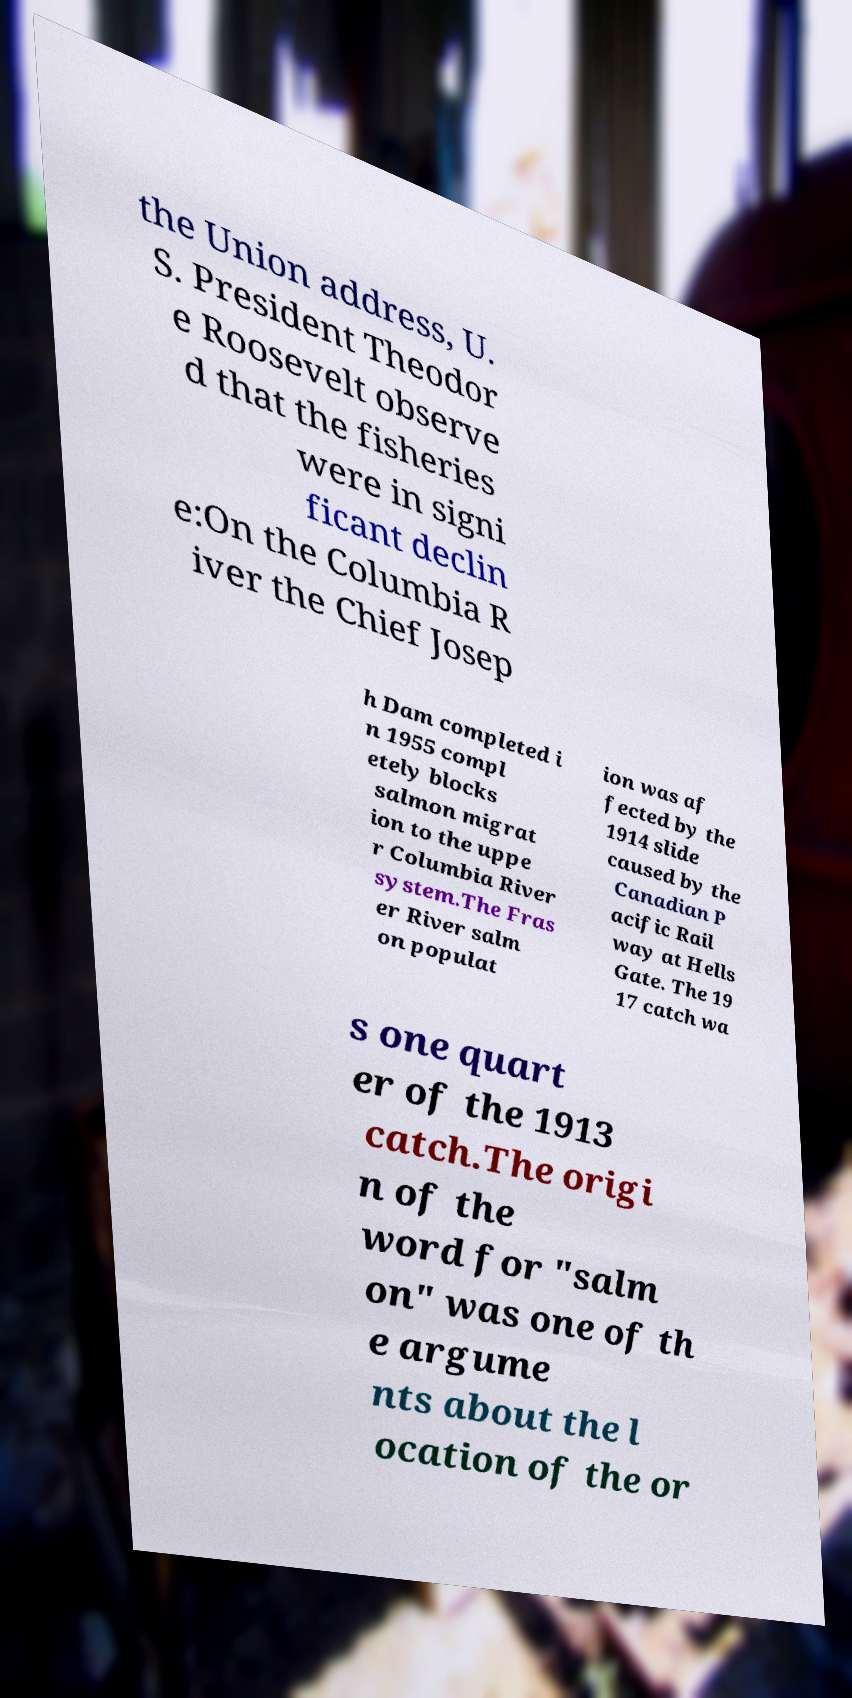Could you extract and type out the text from this image? the Union address, U. S. President Theodor e Roosevelt observe d that the fisheries were in signi ficant declin e:On the Columbia R iver the Chief Josep h Dam completed i n 1955 compl etely blocks salmon migrat ion to the uppe r Columbia River system.The Fras er River salm on populat ion was af fected by the 1914 slide caused by the Canadian P acific Rail way at Hells Gate. The 19 17 catch wa s one quart er of the 1913 catch.The origi n of the word for "salm on" was one of th e argume nts about the l ocation of the or 